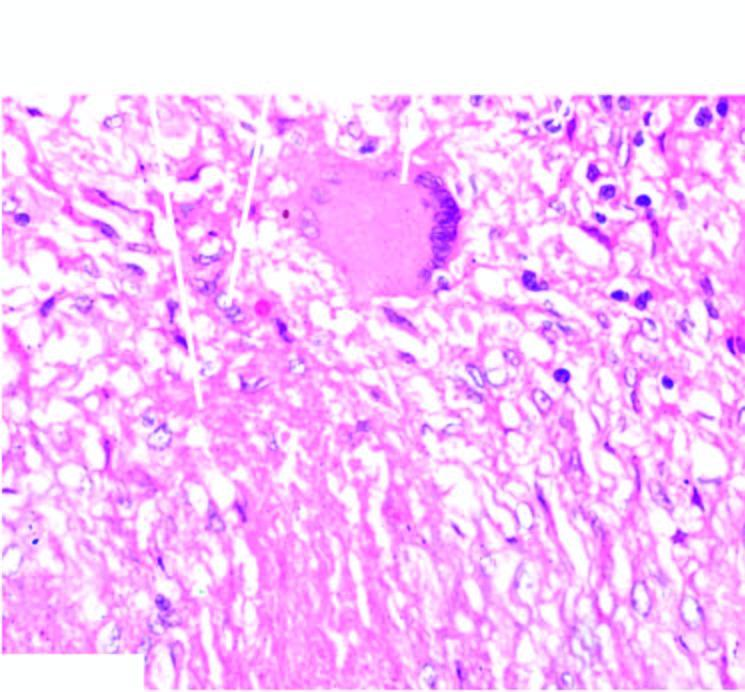what shows lymphocytes?
Answer the question using a single word or phrase. Periphery 